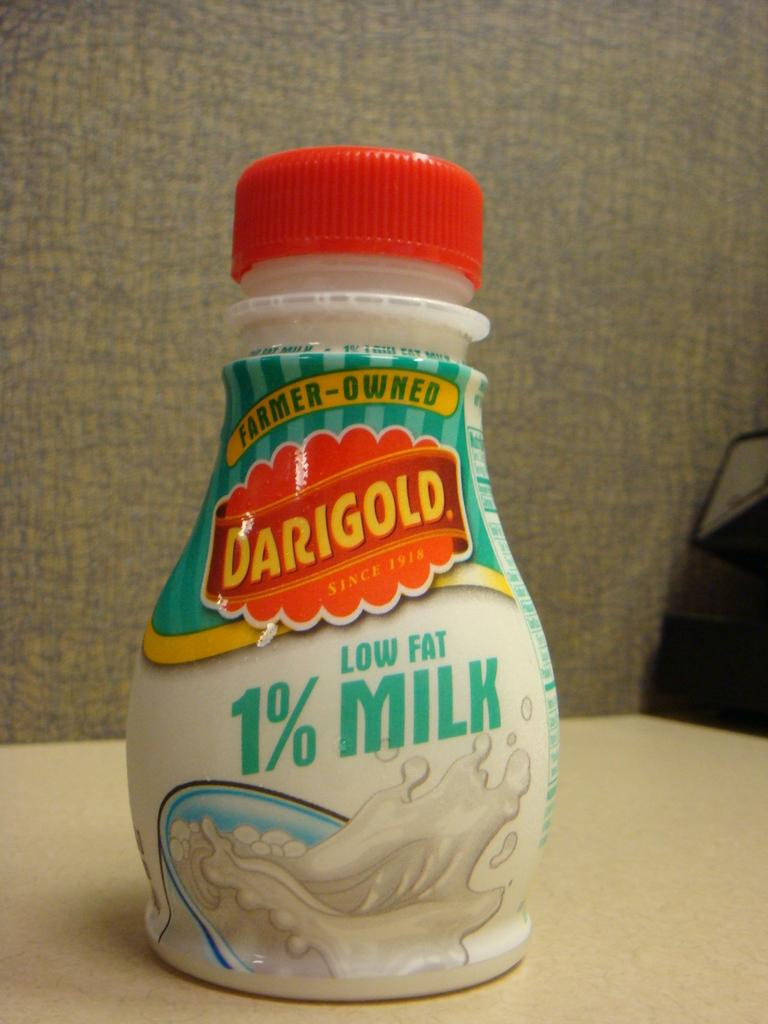What object can be seen in the image? There is a bottle in the image. What color is the cap of the bottle? The bottle has a red cap. Where is the bottle located? The bottle is placed on a table. What is written on the bottle? The word "Dari gold" is written on the bottle. What image is present on the bottle? There is an image of milk on the bottle. Can you tell me how many doctors are present in the image? There are no doctors present in the image; it features a bottle with a red cap, a label, and an image of milk. What type of flesh can be seen on the bottle in the image? There is no flesh present on the bottle in the image; it is a bottle with a red cap, a label, and an image of milk. 